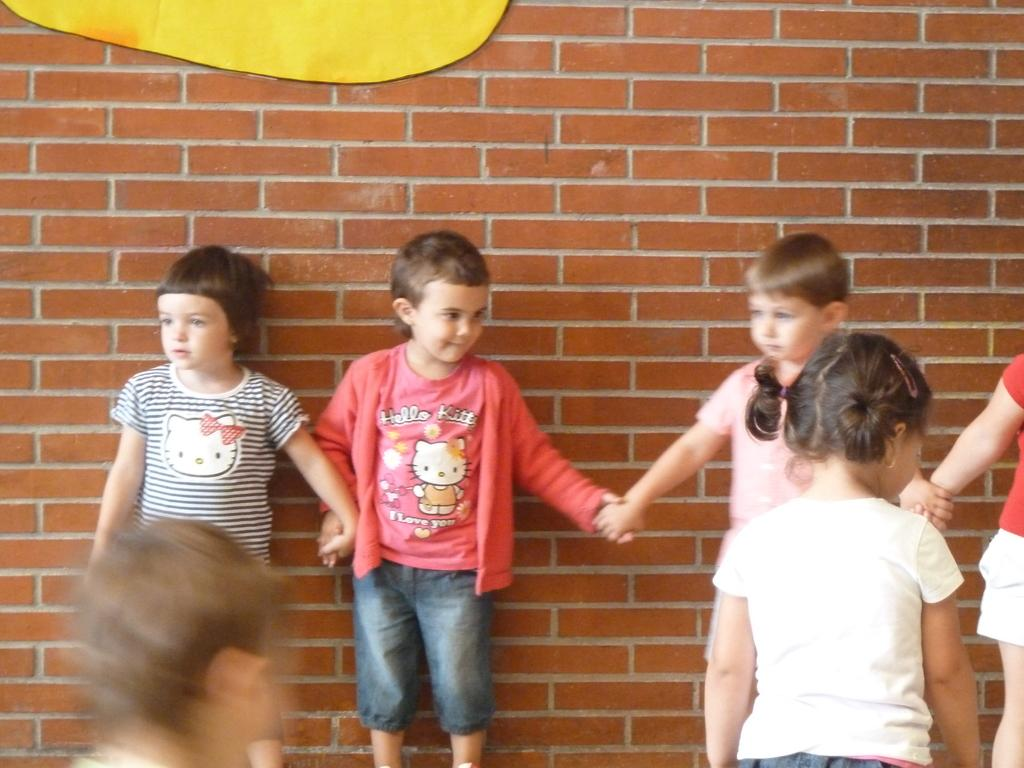Who is present in the image? There are children in the image. What are the children doing in the image? The children are standing on the floor. What can be seen in the background of the image? There is a wall in the background of the image. What type of cannon is being used by the actor in the image? There is no cannon or actor present in the image; it features children standing on the floor with a wall in the background. 